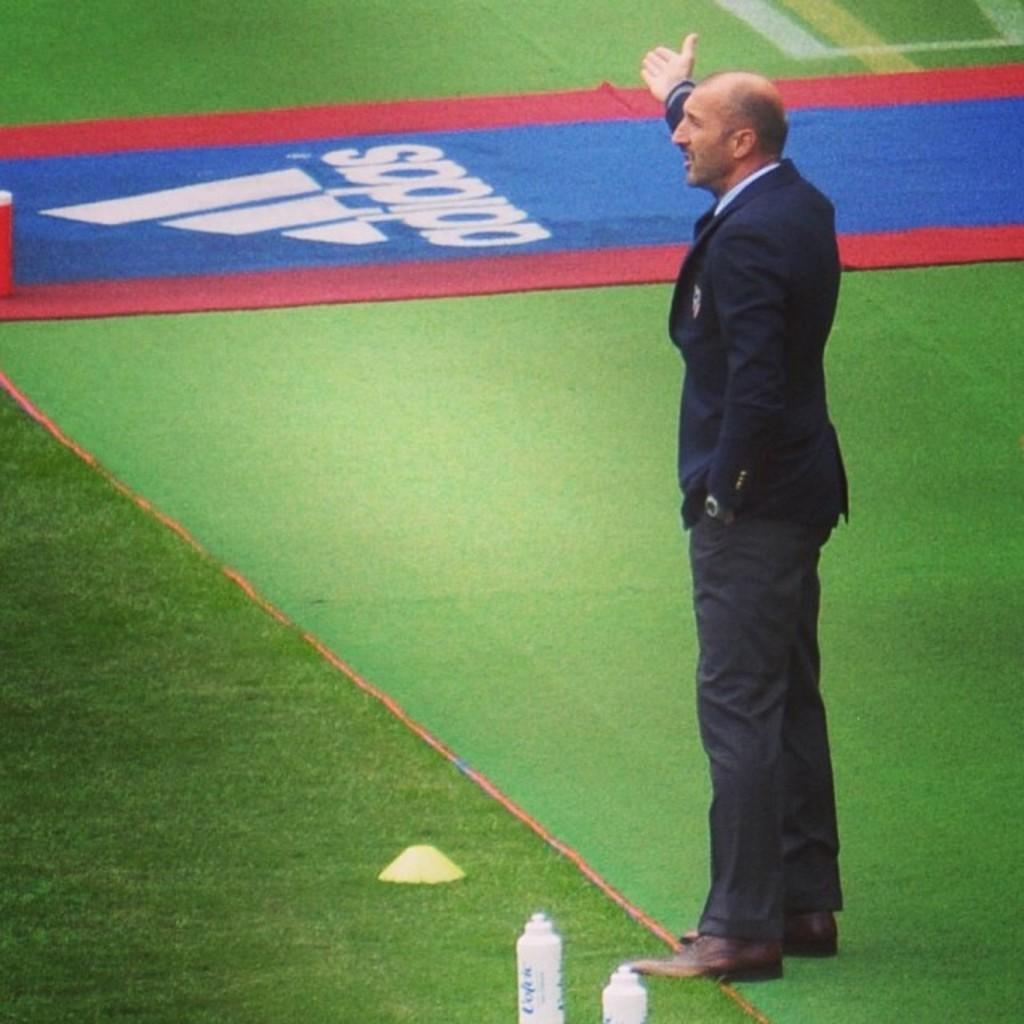In one or two sentences, can you explain what this image depicts? This image consists of a man wearing a blue suit. At the bottom, we can see green grass on the ground. And there are two bottles kept on the ground. And there are two bottles kept on the ground. In the middle, it looks like a carpet. 